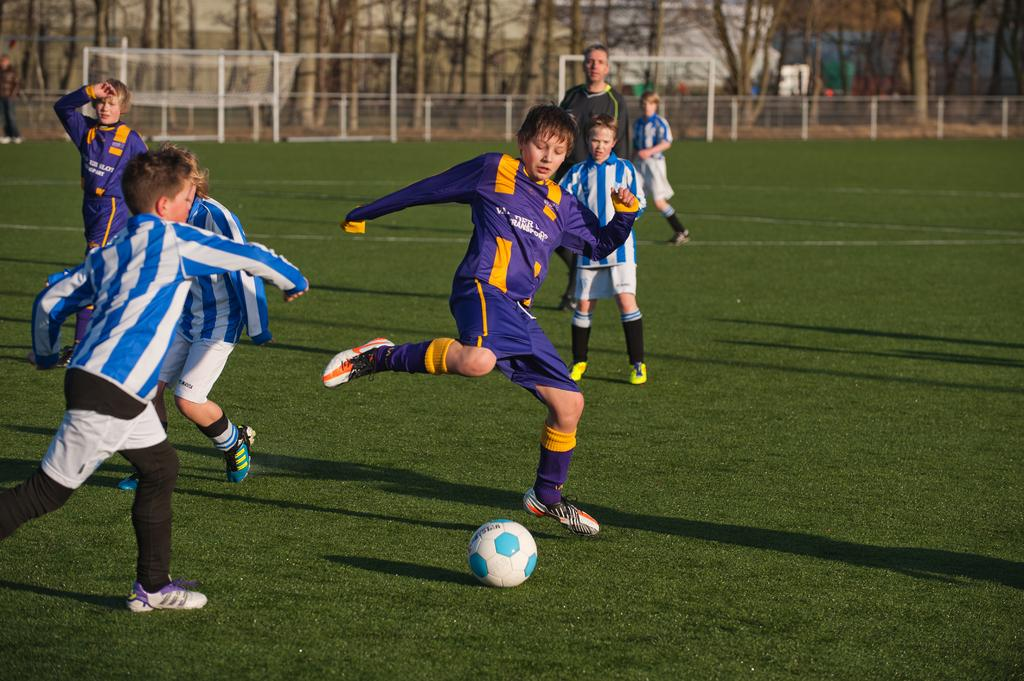What activity are the persons in the image engaged in? The persons in the image are playing a football match. What type of surface is the football match being played on? There is grass on the ground in the image. What can be seen in the background of the image? There are nets, a fence, and trees in the background of the image. What color are the trousers worn by the light in the image? There is no light or trousers present in the image; it features a football match being played on grass with nets, a fence, and trees in the background. 